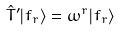<formula> <loc_0><loc_0><loc_500><loc_500>\hat { T } ^ { \prime } | f _ { r } \rangle = \omega ^ { r } | f _ { r } \rangle</formula> 